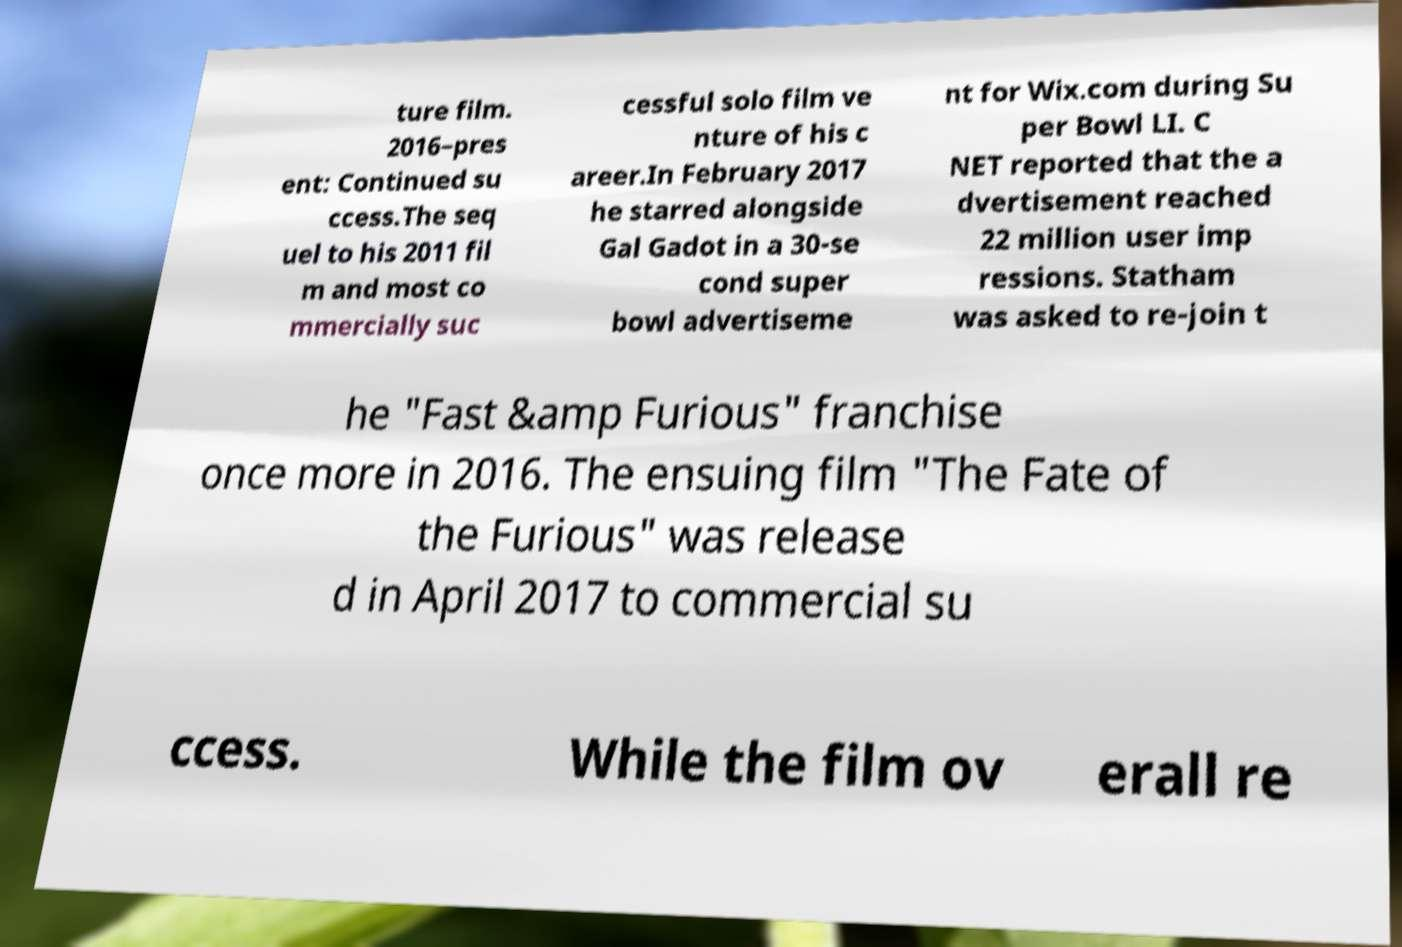Could you assist in decoding the text presented in this image and type it out clearly? ture film. 2016–pres ent: Continued su ccess.The seq uel to his 2011 fil m and most co mmercially suc cessful solo film ve nture of his c areer.In February 2017 he starred alongside Gal Gadot in a 30-se cond super bowl advertiseme nt for Wix.com during Su per Bowl LI. C NET reported that the a dvertisement reached 22 million user imp ressions. Statham was asked to re-join t he "Fast &amp Furious" franchise once more in 2016. The ensuing film "The Fate of the Furious" was release d in April 2017 to commercial su ccess. While the film ov erall re 